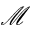Convert formula to latex. <formula><loc_0><loc_0><loc_500><loc_500>\mathcal { M }</formula> 